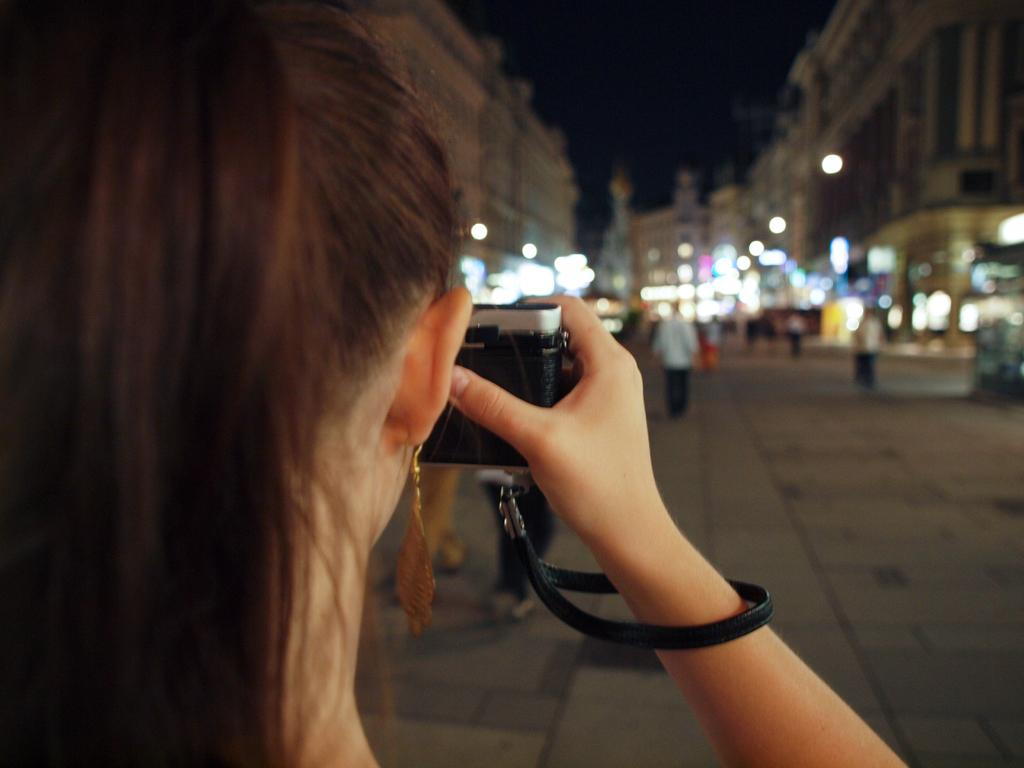Who is the main subject in the image? There is a woman in the image. What is the woman holding in the image? The woman is holding a camera. Who else is present in the image? There is a man in the image. What is the man doing in the image? The man is walking on a road. What type of structures can be seen in the image? Buildings are present in the image. What type of harmony can be heard in the image? There is no audible sound or music present in the image, so it is not possible to determine the type of harmony. 